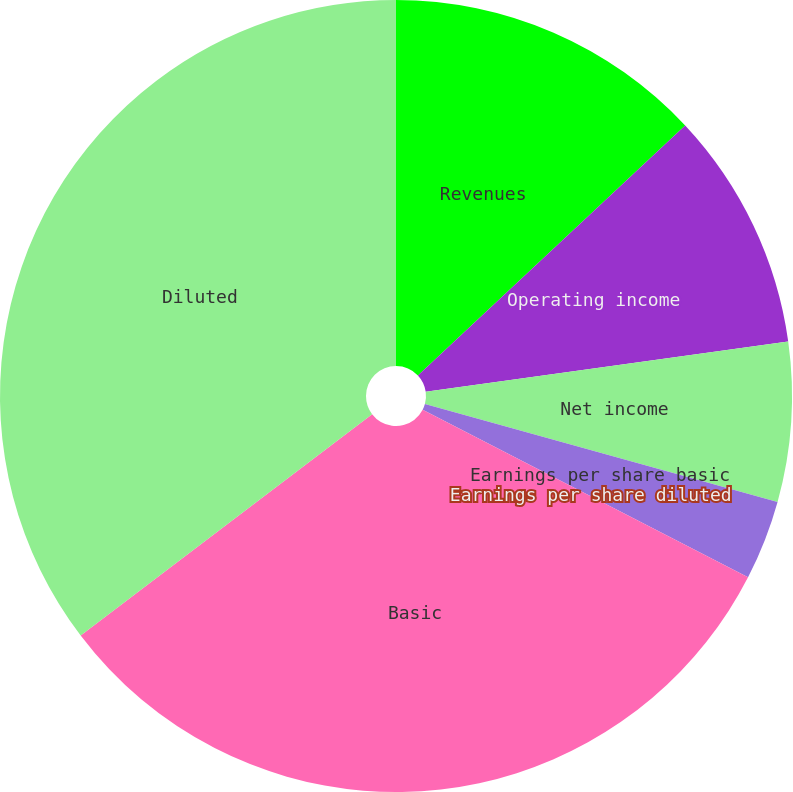<chart> <loc_0><loc_0><loc_500><loc_500><pie_chart><fcel>Revenues<fcel>Operating income<fcel>Net income<fcel>Earnings per share basic<fcel>Earnings per share diluted<fcel>Basic<fcel>Diluted<nl><fcel>13.03%<fcel>9.77%<fcel>6.51%<fcel>3.26%<fcel>0.0%<fcel>32.09%<fcel>35.34%<nl></chart> 